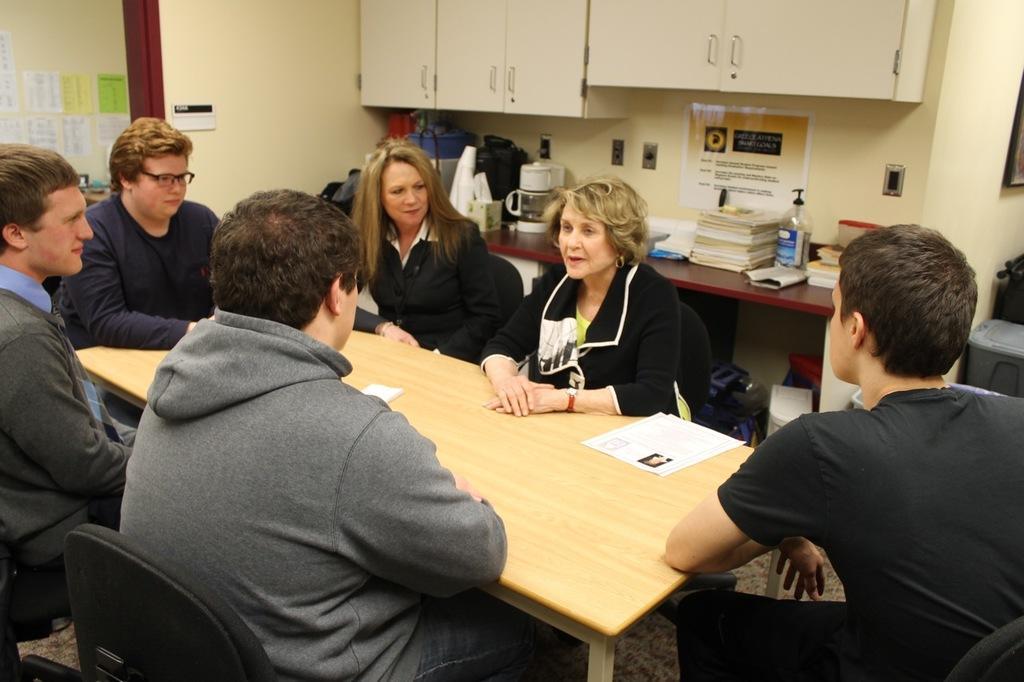Can you describe this image briefly? This is the picture of six people sitting on the chair around the table on which there are some papers and behind them there is a shelf and a desk on which some things are placed. 